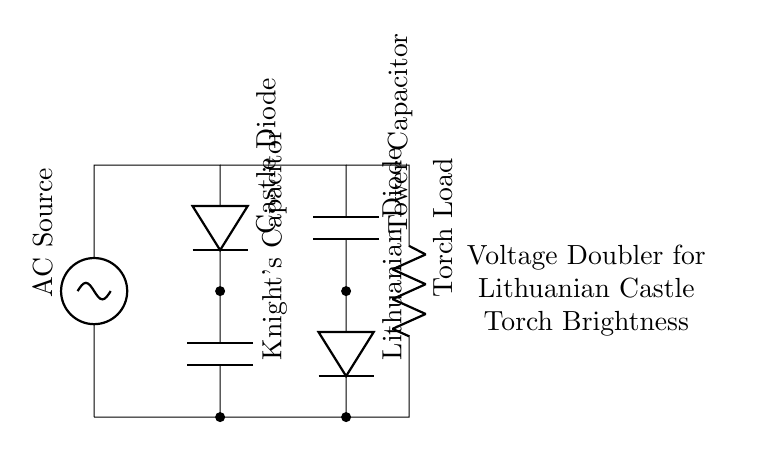What is the type of AC source in this circuit? The diagram indicates an AC source labeled as "AC Source" in the circuit. This identifies the energy input type for the voltage doubler configuration.
Answer: AC Source How many diodes are present in the circuit? There are two diodes labeled as "Castle Diode" and "Lithuanian Diode." Each one is used for rectification in the voltage doubler circuit.
Answer: Two What is the purpose of the Knight's Capacitor? The Knight's Capacitor stores the charge and helps in doubling the voltage output when the AC input is applied. Its role is crucial in enhancing the brightness of the torches.
Answer: Charge storage What is the total capacitance effect achieved in this circuit? The effective capacitance in a voltage doubler will lead to a higher voltage across the load, which means the capacitors work together to increase the output voltage for the torch load. The specific values would depend on the actual components but conceptually the effect is doubling the voltage.
Answer: Doubling What load does this circuit support? The diagram shows a component labeled "Torch Load," which implies this circuit is specifically designed to power the torches in the castle towers with enhanced brightness.
Answer: Torch What is the primary function of the voltage doubler in this application? The primary function is to increase the output voltage for the torches, enabling greater brightness than what would be achieved using a standard AC voltage without the doubler.
Answer: Voltage increase What kind of load is represented in the circuit? The circuit features a resistive load labeled "Torch Load," indicating it consumes electrical energy to produce light.
Answer: Resistive load 